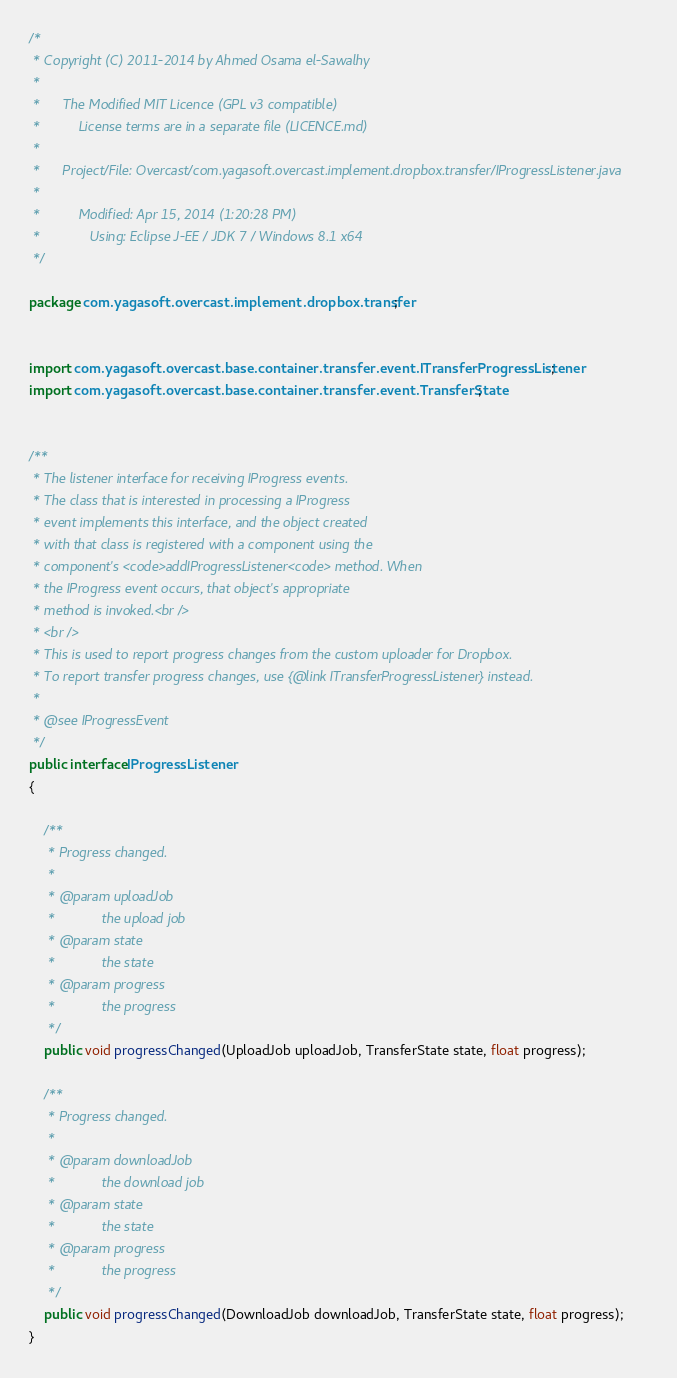<code> <loc_0><loc_0><loc_500><loc_500><_Java_>/*
 * Copyright (C) 2011-2014 by Ahmed Osama el-Sawalhy
 *
 *		The Modified MIT Licence (GPL v3 compatible)
 * 			License terms are in a separate file (LICENCE.md)
 *
 *		Project/File: Overcast/com.yagasoft.overcast.implement.dropbox.transfer/IProgressListener.java
 *
 *			Modified: Apr 15, 2014 (1:20:28 PM)
 *			   Using: Eclipse J-EE / JDK 7 / Windows 8.1 x64
 */

package com.yagasoft.overcast.implement.dropbox.transfer;


import com.yagasoft.overcast.base.container.transfer.event.ITransferProgressListener;
import com.yagasoft.overcast.base.container.transfer.event.TransferState;


/**
 * The listener interface for receiving IProgress events.
 * The class that is interested in processing a IProgress
 * event implements this interface, and the object created
 * with that class is registered with a component using the
 * component's <code>addIProgressListener<code> method. When
 * the IProgress event occurs, that object's appropriate
 * method is invoked.<br />
 * <br />
 * This is used to report progress changes from the custom uploader for Dropbox.
 * To report transfer progress changes, use {@link ITransferProgressListener} instead.
 *
 * @see IProgressEvent
 */
public interface IProgressListener
{
	
	/**
	 * Progress changed.
	 *
	 * @param uploadJob
	 *            the upload job
	 * @param state
	 *            the state
	 * @param progress
	 *            the progress
	 */
	public void progressChanged(UploadJob uploadJob, TransferState state, float progress);
	
	/**
	 * Progress changed.
	 *
	 * @param downloadJob
	 *            the download job
	 * @param state
	 *            the state
	 * @param progress
	 *            the progress
	 */
	public void progressChanged(DownloadJob downloadJob, TransferState state, float progress);
}
</code> 